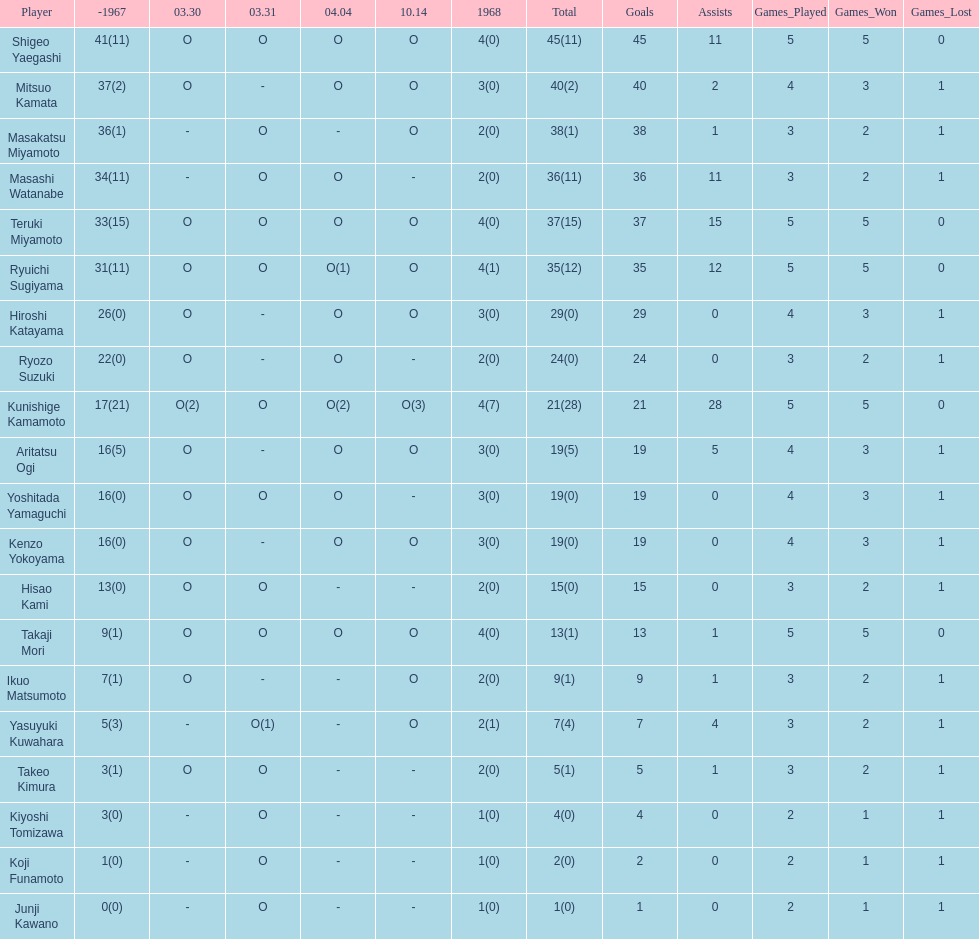Did mitsuo kamata have more than 40 total points? No. 